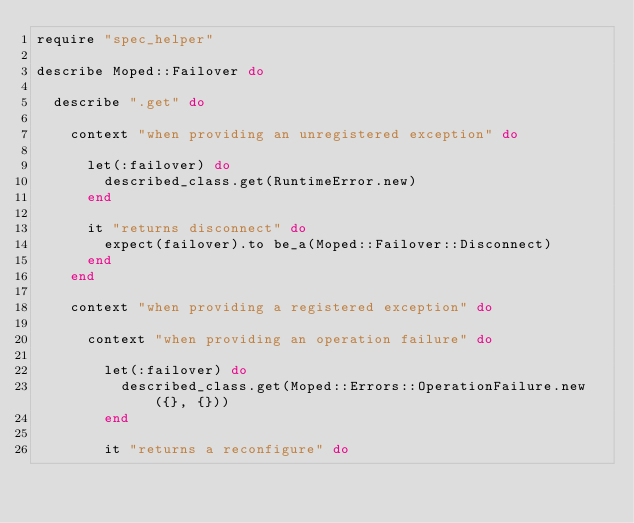Convert code to text. <code><loc_0><loc_0><loc_500><loc_500><_Ruby_>require "spec_helper"

describe Moped::Failover do

  describe ".get" do

    context "when providing an unregistered exception" do

      let(:failover) do
        described_class.get(RuntimeError.new)
      end

      it "returns disconnect" do
        expect(failover).to be_a(Moped::Failover::Disconnect)
      end
    end

    context "when providing a registered exception" do

      context "when providing an operation failure" do

        let(:failover) do
          described_class.get(Moped::Errors::OperationFailure.new({}, {}))
        end

        it "returns a reconfigure" do</code> 